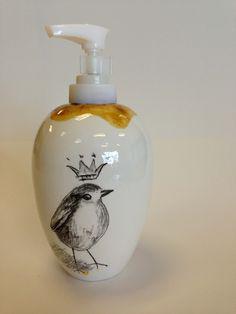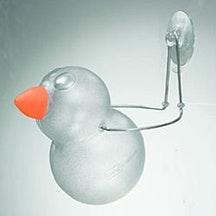The first image is the image on the left, the second image is the image on the right. Considering the images on both sides, is "An image shows one white ceramic-look pump-top dispenser illustrated with a bird likeness." valid? Answer yes or no. Yes. The first image is the image on the left, the second image is the image on the right. For the images displayed, is the sentence "At least one soap dispenser has a spout pointing to the left." factually correct? Answer yes or no. Yes. 